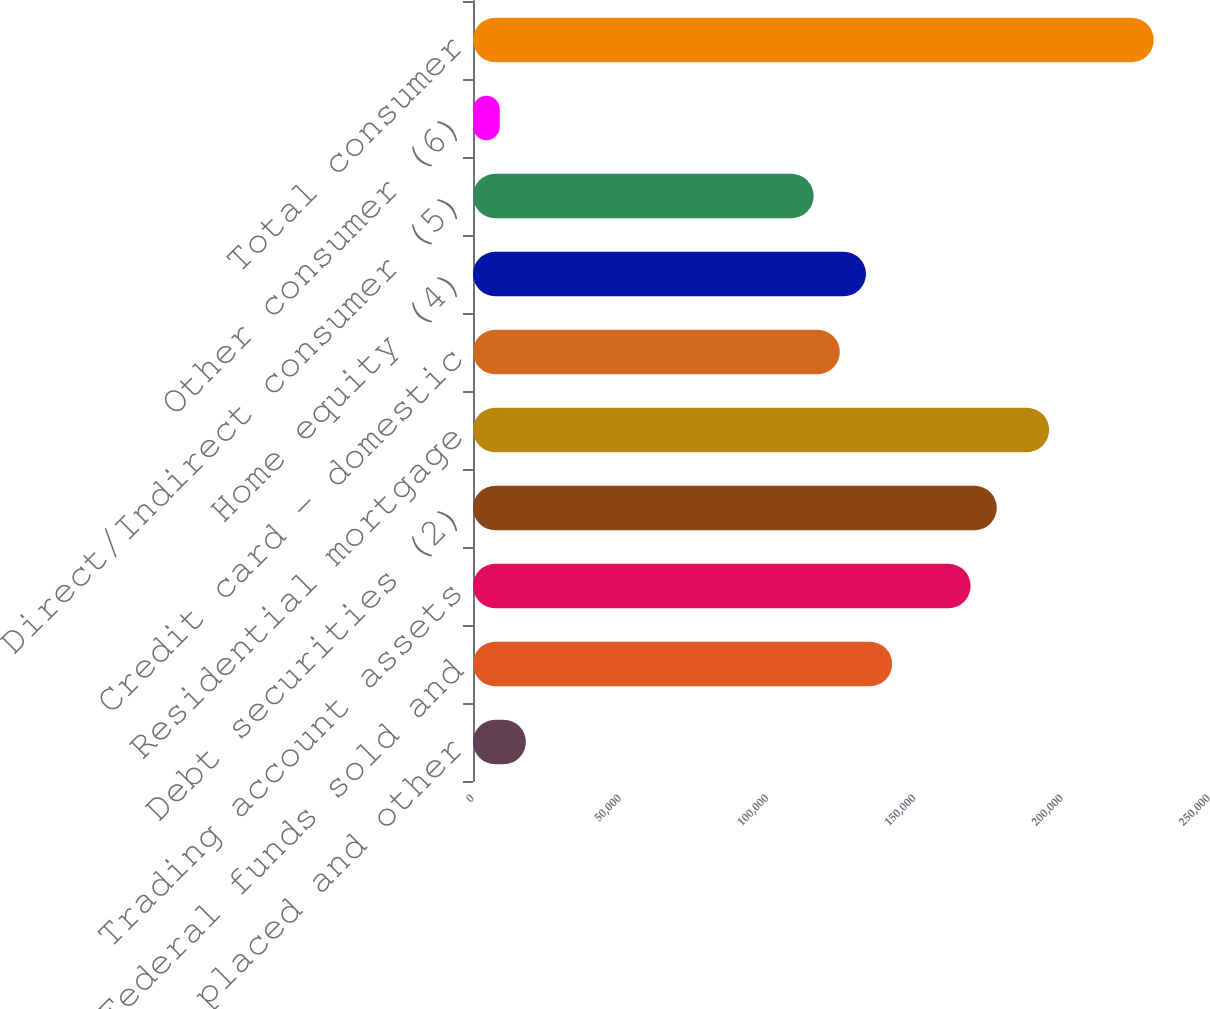<chart> <loc_0><loc_0><loc_500><loc_500><bar_chart><fcel>Time deposits placed and other<fcel>Federal funds sold and<fcel>Trading account assets<fcel>Debt securities (2)<fcel>Residential mortgage<fcel>Credit card - domestic<fcel>Home equity (4)<fcel>Direct/Indirect consumer (5)<fcel>Other consumer (6)<fcel>Total consumer<nl><fcel>17961<fcel>142372<fcel>169032<fcel>177918<fcel>195691<fcel>124599<fcel>133486<fcel>115712<fcel>9074.5<fcel>231237<nl></chart> 